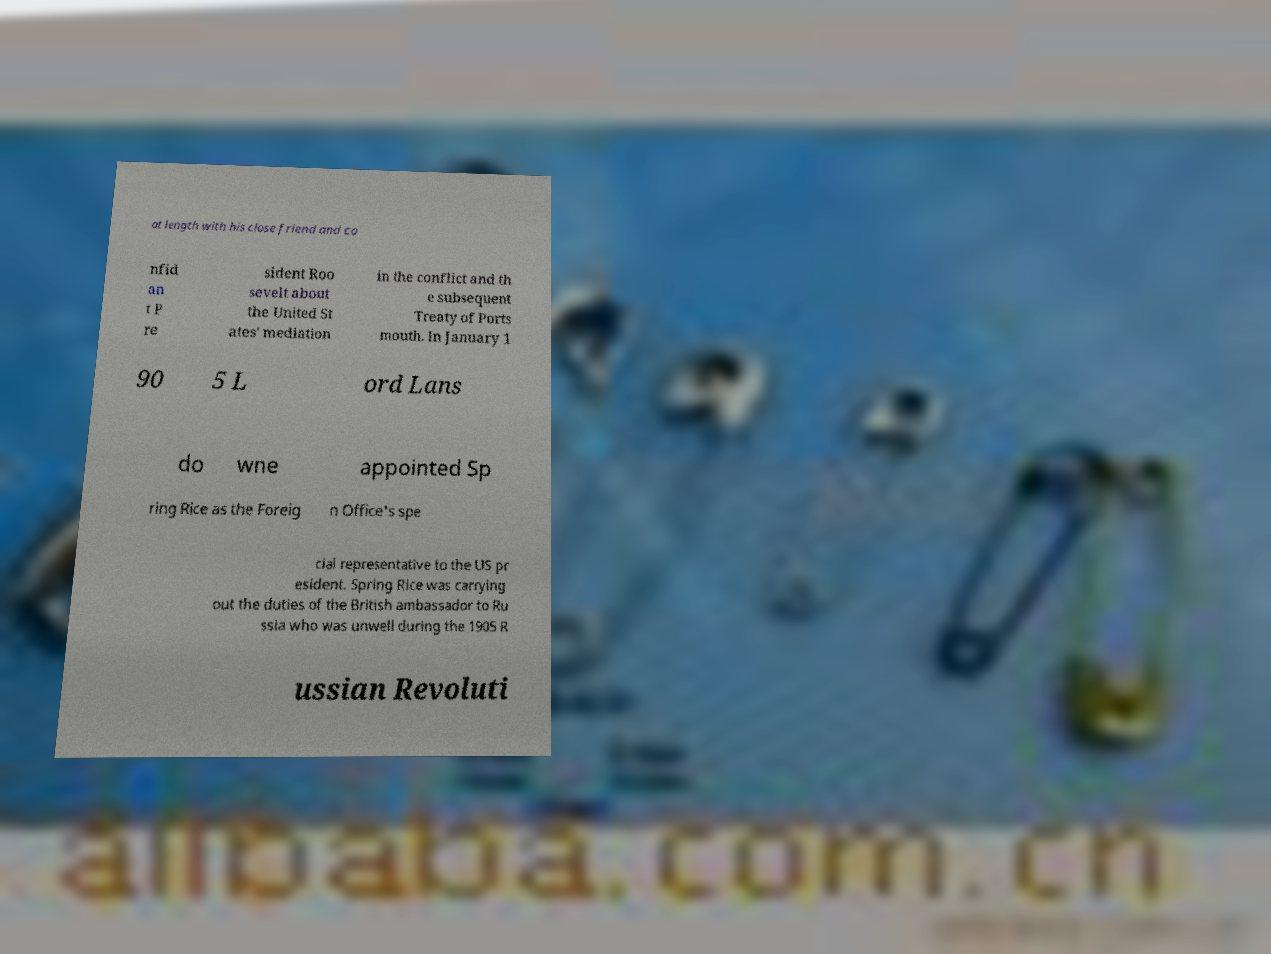Please identify and transcribe the text found in this image. at length with his close friend and co nfid an t P re sident Roo sevelt about the United St ates' mediation in the conflict and th e subsequent Treaty of Ports mouth. In January 1 90 5 L ord Lans do wne appointed Sp ring Rice as the Foreig n Office's spe cial representative to the US pr esident. Spring Rice was carrying out the duties of the British ambassador to Ru ssia who was unwell during the 1905 R ussian Revoluti 